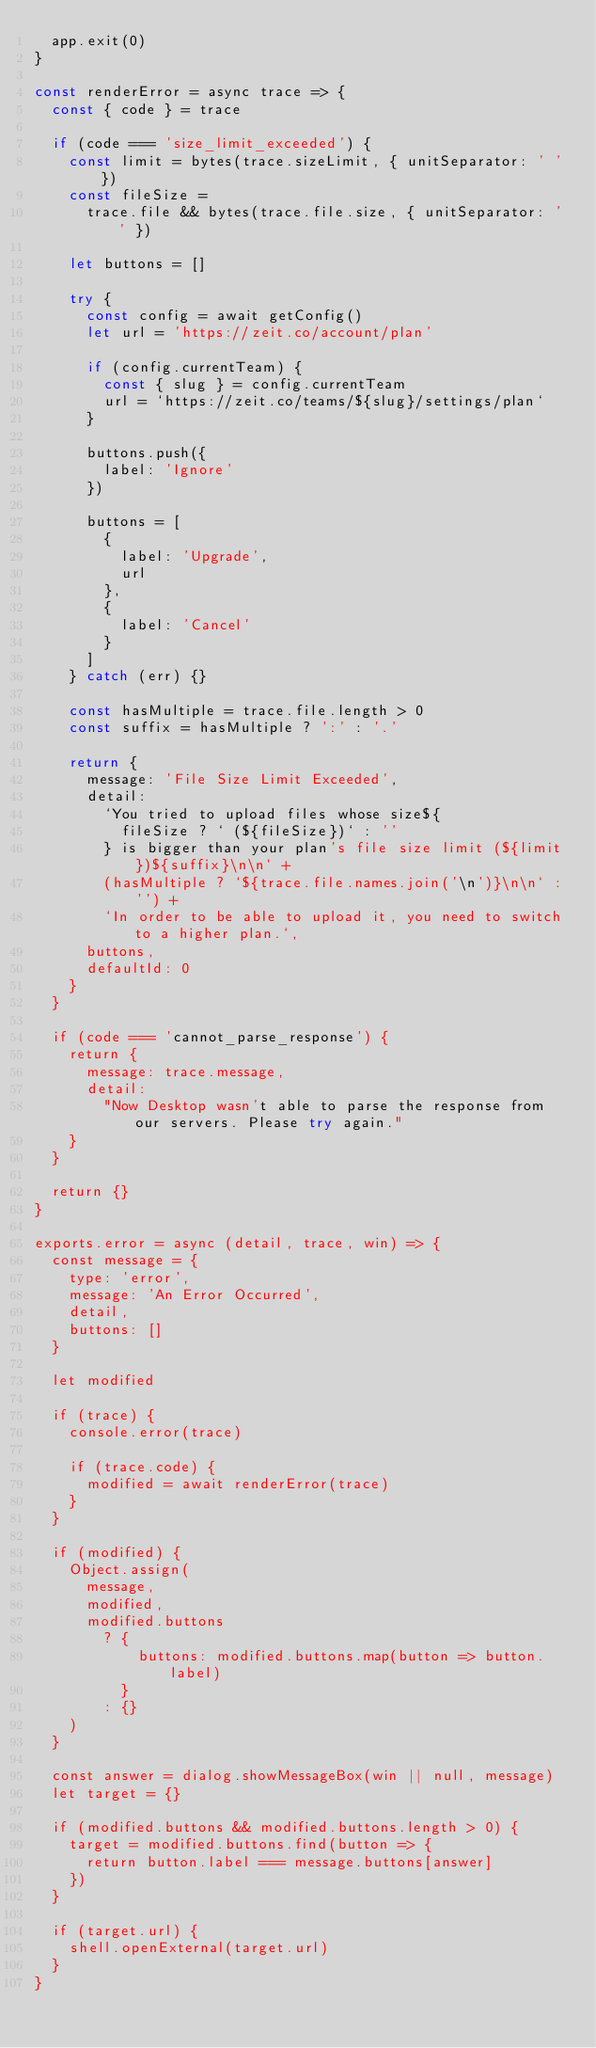<code> <loc_0><loc_0><loc_500><loc_500><_JavaScript_>  app.exit(0)
}

const renderError = async trace => {
  const { code } = trace

  if (code === 'size_limit_exceeded') {
    const limit = bytes(trace.sizeLimit, { unitSeparator: ' ' })
    const fileSize =
      trace.file && bytes(trace.file.size, { unitSeparator: ' ' })

    let buttons = []

    try {
      const config = await getConfig()
      let url = 'https://zeit.co/account/plan'

      if (config.currentTeam) {
        const { slug } = config.currentTeam
        url = `https://zeit.co/teams/${slug}/settings/plan`
      }

      buttons.push({
        label: 'Ignore'
      })

      buttons = [
        {
          label: 'Upgrade',
          url
        },
        {
          label: 'Cancel'
        }
      ]
    } catch (err) {}

    const hasMultiple = trace.file.length > 0
    const suffix = hasMultiple ? ':' : '.'

    return {
      message: 'File Size Limit Exceeded',
      detail:
        `You tried to upload files whose size${
          fileSize ? ` (${fileSize})` : ''
        } is bigger than your plan's file size limit (${limit})${suffix}\n\n` +
        (hasMultiple ? `${trace.file.names.join('\n')}\n\n` : '') +
        `In order to be able to upload it, you need to switch to a higher plan.`,
      buttons,
      defaultId: 0
    }
  }

  if (code === 'cannot_parse_response') {
    return {
      message: trace.message,
      detail:
        "Now Desktop wasn't able to parse the response from our servers. Please try again."
    }
  }

  return {}
}

exports.error = async (detail, trace, win) => {
  const message = {
    type: 'error',
    message: 'An Error Occurred',
    detail,
    buttons: []
  }

  let modified

  if (trace) {
    console.error(trace)

    if (trace.code) {
      modified = await renderError(trace)
    }
  }

  if (modified) {
    Object.assign(
      message,
      modified,
      modified.buttons
        ? {
            buttons: modified.buttons.map(button => button.label)
          }
        : {}
    )
  }

  const answer = dialog.showMessageBox(win || null, message)
  let target = {}

  if (modified.buttons && modified.buttons.length > 0) {
    target = modified.buttons.find(button => {
      return button.label === message.buttons[answer]
    })
  }

  if (target.url) {
    shell.openExternal(target.url)
  }
}
</code> 